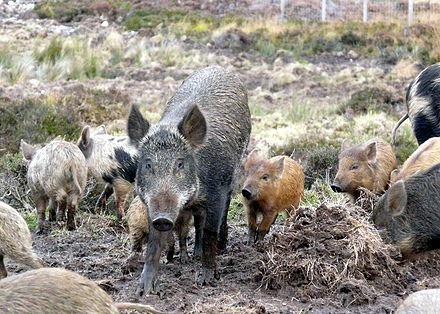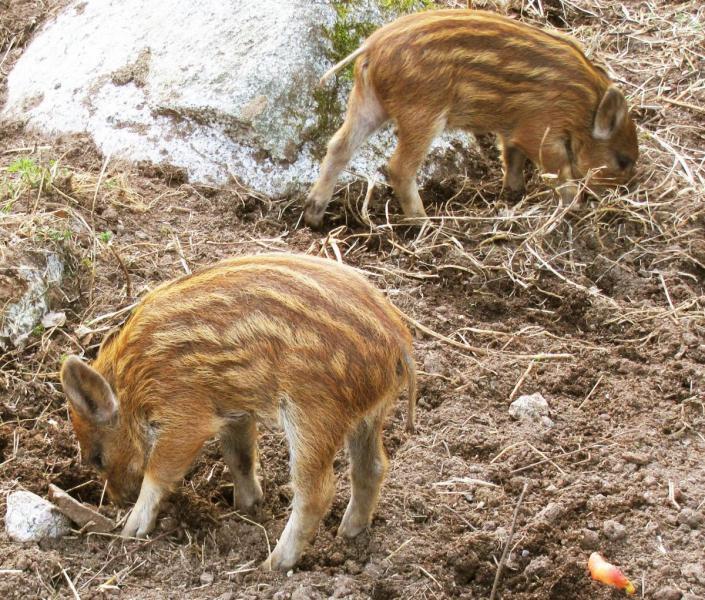The first image is the image on the left, the second image is the image on the right. For the images shown, is this caption "There is a tiger attacking a boar." true? Answer yes or no. No. The first image is the image on the left, the second image is the image on the right. Examine the images to the left and right. Is the description "In one of the image there is a tiger attacking a pig." accurate? Answer yes or no. No. 